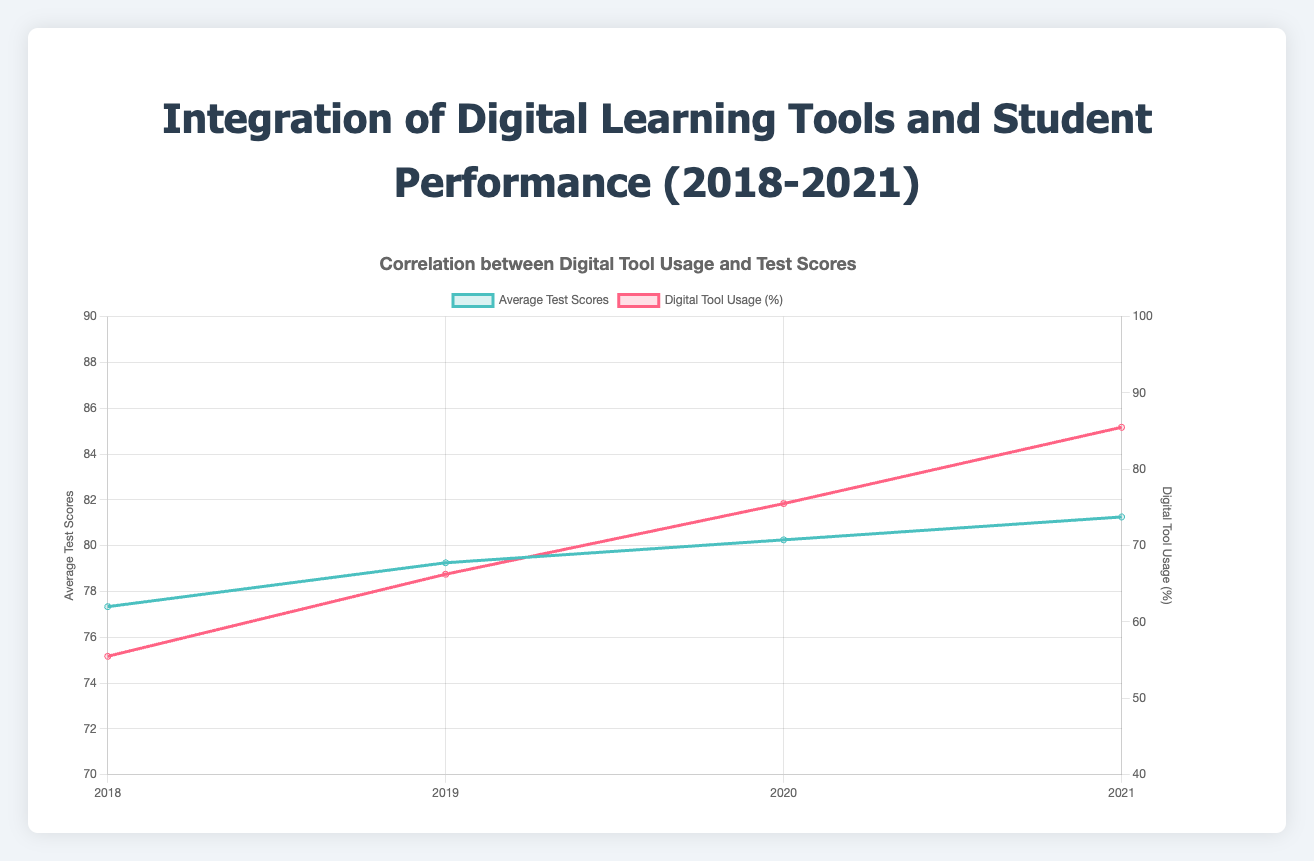What is the average test score in 2020? The data shows the average test scores per year. For 2020, the average test score can be directly read off the chart.
Answer: 81.5 By how much did the digital tool usage percentage increase from 2018 to 2021? From the graph, the digital tool usage in 2018 is 54.42%, and in 2021 it is 85.58%. Subtracting these values gives the increase. 85.58% - 54.42% = 31.16%
Answer: 31.16% Is there a positive correlation between digital tool usage and average test scores? Observing the trend lines for both digital tool usage and average test scores, both appear to increase over the years, suggesting a positive correlation.
Answer: Yes In which year did the average test score first exceed 80? Reviewing the average test scores by year, the first year the average exceeds 80 is visible. This happens in 2019.
Answer: 2019 What is the difference in average test scores between the years 2019 and 2020? Average test score in 2019 is 79.25, and in 2020 it is 81.5. Subtracting the former from the latter gives 81.5 - 79.25 = 2.25.
Answer: 2.25 Which year had the highest digital tool usage percentage? Viewing the digital tool usage line, the highest point on the graph corresponds to the year 2021.
Answer: 2021 How does the digital tool usage trend compare between 2018 and 2020? Comparing the digital tool usage per year, there is a noticeable increase from 2018 to 2020, rising from 54.42% in 2018 to 72.83% in 2020.
Answer: Increase What are the average test scores and digital tool usage in 2021? From the chart data, the average test score in 2021 is 82.58, and the digital tool usage is 85.58%.
Answer: 82.58 for test scores, 85.58% for digital tool usage 